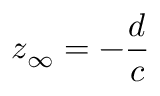Convert formula to latex. <formula><loc_0><loc_0><loc_500><loc_500>z _ { \infty } = - { \frac { d } { c } }</formula> 